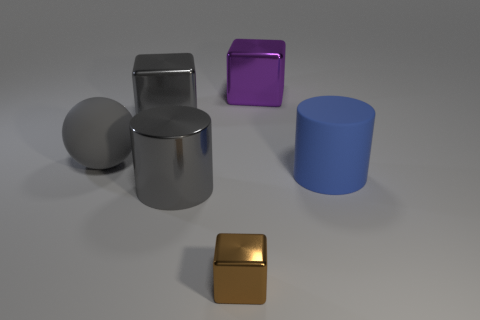Add 1 big shiny things. How many objects exist? 7 Subtract all spheres. How many objects are left? 5 Add 5 purple blocks. How many purple blocks exist? 6 Subtract 0 green cubes. How many objects are left? 6 Subtract all small brown blocks. Subtract all gray things. How many objects are left? 2 Add 5 matte spheres. How many matte spheres are left? 6 